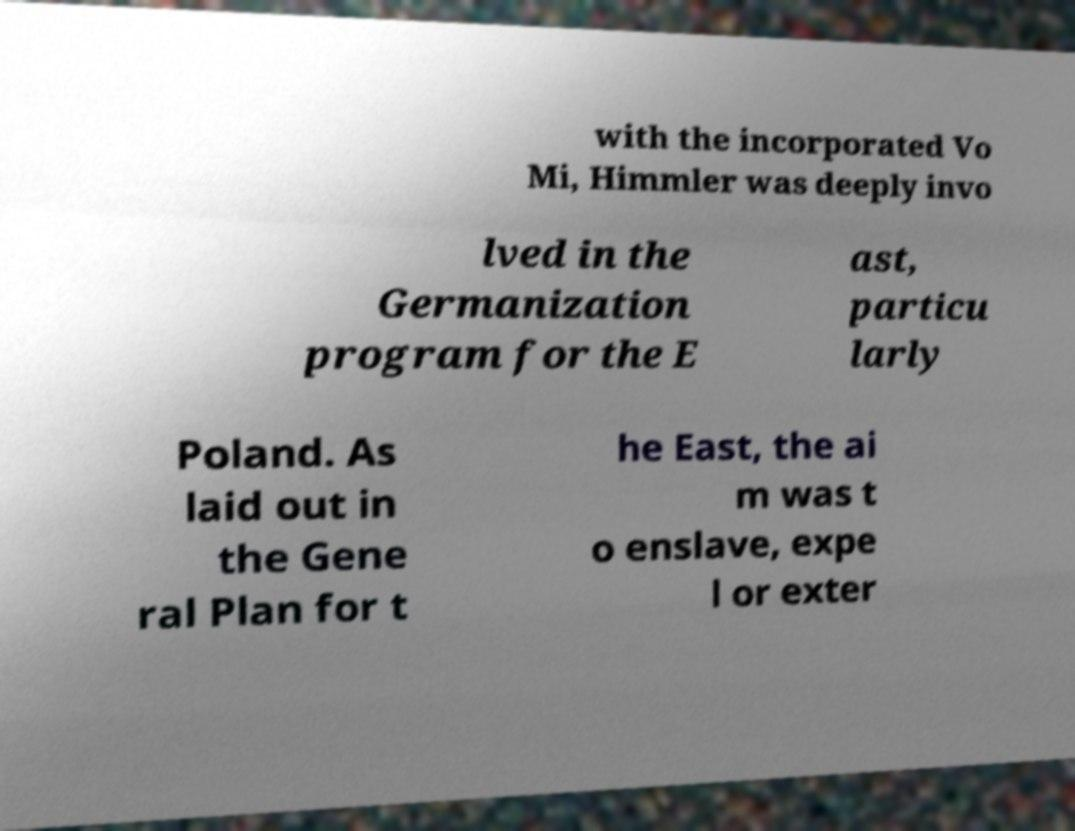What messages or text are displayed in this image? I need them in a readable, typed format. with the incorporated Vo Mi, Himmler was deeply invo lved in the Germanization program for the E ast, particu larly Poland. As laid out in the Gene ral Plan for t he East, the ai m was t o enslave, expe l or exter 